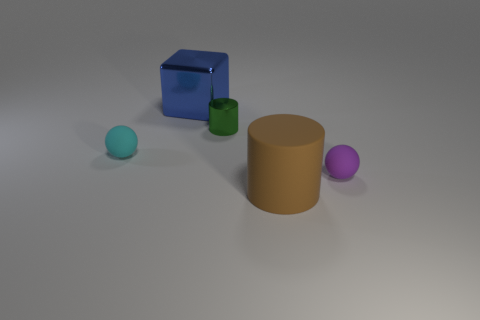What number of large blue objects are there?
Offer a terse response. 1. What number of other tiny objects are the same material as the cyan thing?
Your answer should be compact. 1. There is another object that is the same shape as the cyan thing; what size is it?
Your response must be concise. Small. What is the brown object made of?
Ensure brevity in your answer.  Rubber. What material is the large thing on the right side of the big blue object behind the tiny object that is in front of the cyan rubber thing?
Your response must be concise. Rubber. Is there any other thing that has the same shape as the tiny purple object?
Ensure brevity in your answer.  Yes. What color is the other small thing that is the same shape as the purple object?
Ensure brevity in your answer.  Cyan. Do the small rubber sphere left of the blue block and the small sphere on the right side of the small cyan rubber thing have the same color?
Offer a terse response. No. Is the number of cyan spheres that are left of the small purple matte thing greater than the number of large cyan things?
Ensure brevity in your answer.  Yes. What number of other objects are there of the same size as the brown cylinder?
Make the answer very short. 1. 